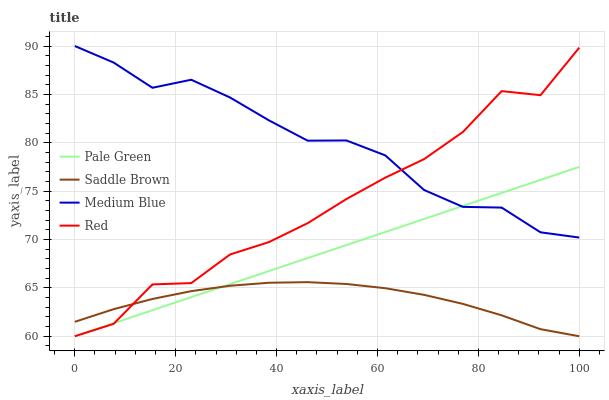Does Medium Blue have the minimum area under the curve?
Answer yes or no. No. Does Saddle Brown have the maximum area under the curve?
Answer yes or no. No. Is Medium Blue the smoothest?
Answer yes or no. No. Is Medium Blue the roughest?
Answer yes or no. No. Does Medium Blue have the lowest value?
Answer yes or no. No. Does Saddle Brown have the highest value?
Answer yes or no. No. Is Saddle Brown less than Medium Blue?
Answer yes or no. Yes. Is Medium Blue greater than Saddle Brown?
Answer yes or no. Yes. Does Saddle Brown intersect Medium Blue?
Answer yes or no. No. 